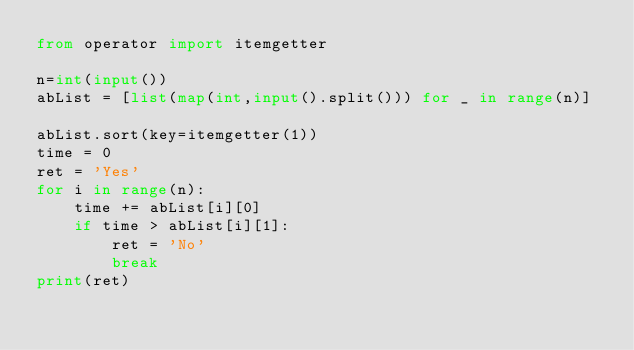Convert code to text. <code><loc_0><loc_0><loc_500><loc_500><_Python_>from operator import itemgetter

n=int(input())
abList = [list(map(int,input().split())) for _ in range(n)]

abList.sort(key=itemgetter(1))
time = 0
ret = 'Yes'
for i in range(n):
    time += abList[i][0]
    if time > abList[i][1]:
        ret = 'No'
        break
print(ret)</code> 